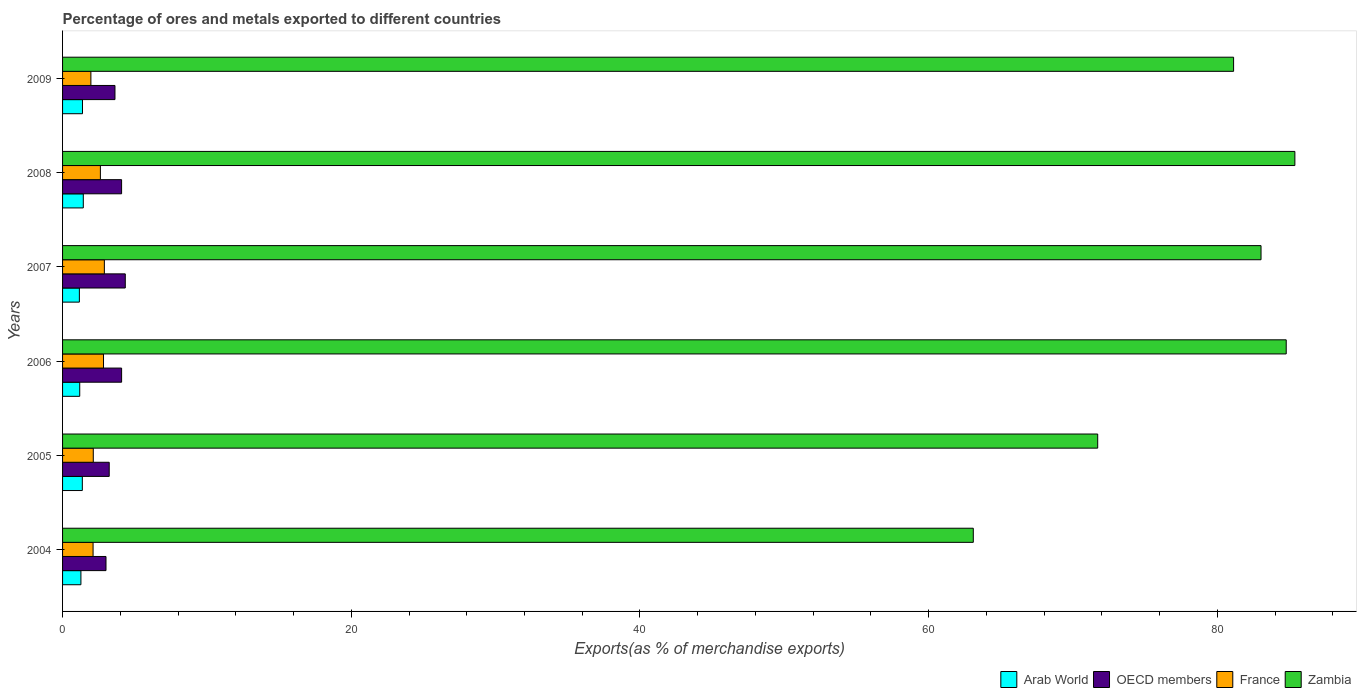How many different coloured bars are there?
Make the answer very short. 4. Are the number of bars per tick equal to the number of legend labels?
Offer a terse response. Yes. How many bars are there on the 3rd tick from the top?
Your answer should be compact. 4. In how many cases, is the number of bars for a given year not equal to the number of legend labels?
Your answer should be very brief. 0. What is the percentage of exports to different countries in Arab World in 2009?
Ensure brevity in your answer.  1.38. Across all years, what is the maximum percentage of exports to different countries in Arab World?
Make the answer very short. 1.44. Across all years, what is the minimum percentage of exports to different countries in France?
Provide a succinct answer. 1.96. In which year was the percentage of exports to different countries in Arab World minimum?
Offer a terse response. 2007. What is the total percentage of exports to different countries in Arab World in the graph?
Provide a short and direct response. 7.81. What is the difference between the percentage of exports to different countries in Arab World in 2007 and that in 2009?
Give a very brief answer. -0.22. What is the difference between the percentage of exports to different countries in OECD members in 2004 and the percentage of exports to different countries in Zambia in 2005?
Give a very brief answer. -68.7. What is the average percentage of exports to different countries in France per year?
Give a very brief answer. 2.43. In the year 2007, what is the difference between the percentage of exports to different countries in Arab World and percentage of exports to different countries in France?
Your answer should be very brief. -1.73. What is the ratio of the percentage of exports to different countries in Arab World in 2007 to that in 2008?
Your answer should be compact. 0.81. Is the difference between the percentage of exports to different countries in Arab World in 2007 and 2009 greater than the difference between the percentage of exports to different countries in France in 2007 and 2009?
Offer a terse response. No. What is the difference between the highest and the second highest percentage of exports to different countries in Arab World?
Give a very brief answer. 0.06. What is the difference between the highest and the lowest percentage of exports to different countries in France?
Offer a terse response. 0.93. Is it the case that in every year, the sum of the percentage of exports to different countries in Arab World and percentage of exports to different countries in OECD members is greater than the sum of percentage of exports to different countries in Zambia and percentage of exports to different countries in France?
Offer a terse response. No. What does the 4th bar from the bottom in 2007 represents?
Your answer should be compact. Zambia. Is it the case that in every year, the sum of the percentage of exports to different countries in Arab World and percentage of exports to different countries in France is greater than the percentage of exports to different countries in Zambia?
Provide a succinct answer. No. Are all the bars in the graph horizontal?
Offer a very short reply. Yes. Are the values on the major ticks of X-axis written in scientific E-notation?
Offer a very short reply. No. Does the graph contain grids?
Your answer should be very brief. No. Where does the legend appear in the graph?
Provide a short and direct response. Bottom right. How many legend labels are there?
Make the answer very short. 4. What is the title of the graph?
Your answer should be compact. Percentage of ores and metals exported to different countries. Does "Micronesia" appear as one of the legend labels in the graph?
Offer a very short reply. No. What is the label or title of the X-axis?
Ensure brevity in your answer.  Exports(as % of merchandise exports). What is the Exports(as % of merchandise exports) in Arab World in 2004?
Provide a succinct answer. 1.27. What is the Exports(as % of merchandise exports) of OECD members in 2004?
Make the answer very short. 3.01. What is the Exports(as % of merchandise exports) of France in 2004?
Provide a short and direct response. 2.11. What is the Exports(as % of merchandise exports) of Zambia in 2004?
Offer a very short reply. 63.09. What is the Exports(as % of merchandise exports) in Arab World in 2005?
Provide a succinct answer. 1.37. What is the Exports(as % of merchandise exports) in OECD members in 2005?
Keep it short and to the point. 3.23. What is the Exports(as % of merchandise exports) in France in 2005?
Keep it short and to the point. 2.13. What is the Exports(as % of merchandise exports) in Zambia in 2005?
Your answer should be compact. 71.71. What is the Exports(as % of merchandise exports) of Arab World in 2006?
Your answer should be very brief. 1.19. What is the Exports(as % of merchandise exports) of OECD members in 2006?
Ensure brevity in your answer.  4.09. What is the Exports(as % of merchandise exports) in France in 2006?
Ensure brevity in your answer.  2.84. What is the Exports(as % of merchandise exports) in Zambia in 2006?
Make the answer very short. 84.77. What is the Exports(as % of merchandise exports) in Arab World in 2007?
Your response must be concise. 1.16. What is the Exports(as % of merchandise exports) in OECD members in 2007?
Keep it short and to the point. 4.35. What is the Exports(as % of merchandise exports) in France in 2007?
Provide a short and direct response. 2.9. What is the Exports(as % of merchandise exports) in Zambia in 2007?
Give a very brief answer. 83.03. What is the Exports(as % of merchandise exports) in Arab World in 2008?
Give a very brief answer. 1.44. What is the Exports(as % of merchandise exports) in OECD members in 2008?
Provide a succinct answer. 4.09. What is the Exports(as % of merchandise exports) of France in 2008?
Ensure brevity in your answer.  2.62. What is the Exports(as % of merchandise exports) of Zambia in 2008?
Offer a terse response. 85.37. What is the Exports(as % of merchandise exports) of Arab World in 2009?
Provide a short and direct response. 1.38. What is the Exports(as % of merchandise exports) of OECD members in 2009?
Your response must be concise. 3.63. What is the Exports(as % of merchandise exports) of France in 2009?
Your answer should be very brief. 1.96. What is the Exports(as % of merchandise exports) in Zambia in 2009?
Your answer should be compact. 81.13. Across all years, what is the maximum Exports(as % of merchandise exports) in Arab World?
Offer a very short reply. 1.44. Across all years, what is the maximum Exports(as % of merchandise exports) of OECD members?
Give a very brief answer. 4.35. Across all years, what is the maximum Exports(as % of merchandise exports) of France?
Ensure brevity in your answer.  2.9. Across all years, what is the maximum Exports(as % of merchandise exports) in Zambia?
Your answer should be compact. 85.37. Across all years, what is the minimum Exports(as % of merchandise exports) in Arab World?
Your answer should be compact. 1.16. Across all years, what is the minimum Exports(as % of merchandise exports) of OECD members?
Keep it short and to the point. 3.01. Across all years, what is the minimum Exports(as % of merchandise exports) in France?
Give a very brief answer. 1.96. Across all years, what is the minimum Exports(as % of merchandise exports) of Zambia?
Provide a short and direct response. 63.09. What is the total Exports(as % of merchandise exports) in Arab World in the graph?
Make the answer very short. 7.81. What is the total Exports(as % of merchandise exports) in OECD members in the graph?
Provide a succinct answer. 22.4. What is the total Exports(as % of merchandise exports) of France in the graph?
Your answer should be very brief. 14.56. What is the total Exports(as % of merchandise exports) of Zambia in the graph?
Give a very brief answer. 469.11. What is the difference between the Exports(as % of merchandise exports) of Arab World in 2004 and that in 2005?
Your answer should be very brief. -0.1. What is the difference between the Exports(as % of merchandise exports) in OECD members in 2004 and that in 2005?
Provide a succinct answer. -0.22. What is the difference between the Exports(as % of merchandise exports) of France in 2004 and that in 2005?
Your response must be concise. -0.01. What is the difference between the Exports(as % of merchandise exports) in Zambia in 2004 and that in 2005?
Give a very brief answer. -8.62. What is the difference between the Exports(as % of merchandise exports) of Arab World in 2004 and that in 2006?
Provide a succinct answer. 0.08. What is the difference between the Exports(as % of merchandise exports) in OECD members in 2004 and that in 2006?
Keep it short and to the point. -1.08. What is the difference between the Exports(as % of merchandise exports) of France in 2004 and that in 2006?
Offer a very short reply. -0.72. What is the difference between the Exports(as % of merchandise exports) in Zambia in 2004 and that in 2006?
Keep it short and to the point. -21.68. What is the difference between the Exports(as % of merchandise exports) of Arab World in 2004 and that in 2007?
Offer a very short reply. 0.11. What is the difference between the Exports(as % of merchandise exports) in OECD members in 2004 and that in 2007?
Keep it short and to the point. -1.34. What is the difference between the Exports(as % of merchandise exports) in France in 2004 and that in 2007?
Offer a terse response. -0.78. What is the difference between the Exports(as % of merchandise exports) in Zambia in 2004 and that in 2007?
Provide a succinct answer. -19.93. What is the difference between the Exports(as % of merchandise exports) in Arab World in 2004 and that in 2008?
Your answer should be compact. -0.17. What is the difference between the Exports(as % of merchandise exports) in OECD members in 2004 and that in 2008?
Provide a short and direct response. -1.08. What is the difference between the Exports(as % of merchandise exports) in France in 2004 and that in 2008?
Your answer should be very brief. -0.51. What is the difference between the Exports(as % of merchandise exports) of Zambia in 2004 and that in 2008?
Provide a succinct answer. -22.28. What is the difference between the Exports(as % of merchandise exports) of Arab World in 2004 and that in 2009?
Keep it short and to the point. -0.11. What is the difference between the Exports(as % of merchandise exports) of OECD members in 2004 and that in 2009?
Provide a short and direct response. -0.62. What is the difference between the Exports(as % of merchandise exports) of France in 2004 and that in 2009?
Give a very brief answer. 0.15. What is the difference between the Exports(as % of merchandise exports) in Zambia in 2004 and that in 2009?
Make the answer very short. -18.03. What is the difference between the Exports(as % of merchandise exports) in Arab World in 2005 and that in 2006?
Keep it short and to the point. 0.18. What is the difference between the Exports(as % of merchandise exports) in OECD members in 2005 and that in 2006?
Your answer should be very brief. -0.86. What is the difference between the Exports(as % of merchandise exports) in France in 2005 and that in 2006?
Keep it short and to the point. -0.71. What is the difference between the Exports(as % of merchandise exports) in Zambia in 2005 and that in 2006?
Offer a terse response. -13.06. What is the difference between the Exports(as % of merchandise exports) of Arab World in 2005 and that in 2007?
Offer a very short reply. 0.2. What is the difference between the Exports(as % of merchandise exports) in OECD members in 2005 and that in 2007?
Give a very brief answer. -1.11. What is the difference between the Exports(as % of merchandise exports) of France in 2005 and that in 2007?
Keep it short and to the point. -0.77. What is the difference between the Exports(as % of merchandise exports) of Zambia in 2005 and that in 2007?
Your answer should be very brief. -11.32. What is the difference between the Exports(as % of merchandise exports) of Arab World in 2005 and that in 2008?
Your answer should be compact. -0.07. What is the difference between the Exports(as % of merchandise exports) in OECD members in 2005 and that in 2008?
Give a very brief answer. -0.86. What is the difference between the Exports(as % of merchandise exports) in France in 2005 and that in 2008?
Offer a terse response. -0.49. What is the difference between the Exports(as % of merchandise exports) in Zambia in 2005 and that in 2008?
Your answer should be compact. -13.66. What is the difference between the Exports(as % of merchandise exports) of Arab World in 2005 and that in 2009?
Give a very brief answer. -0.01. What is the difference between the Exports(as % of merchandise exports) of OECD members in 2005 and that in 2009?
Your answer should be compact. -0.4. What is the difference between the Exports(as % of merchandise exports) of France in 2005 and that in 2009?
Your answer should be very brief. 0.17. What is the difference between the Exports(as % of merchandise exports) of Zambia in 2005 and that in 2009?
Make the answer very short. -9.41. What is the difference between the Exports(as % of merchandise exports) of Arab World in 2006 and that in 2007?
Ensure brevity in your answer.  0.03. What is the difference between the Exports(as % of merchandise exports) in OECD members in 2006 and that in 2007?
Offer a very short reply. -0.25. What is the difference between the Exports(as % of merchandise exports) in France in 2006 and that in 2007?
Offer a terse response. -0.06. What is the difference between the Exports(as % of merchandise exports) in Zambia in 2006 and that in 2007?
Offer a very short reply. 1.74. What is the difference between the Exports(as % of merchandise exports) of Arab World in 2006 and that in 2008?
Keep it short and to the point. -0.25. What is the difference between the Exports(as % of merchandise exports) in OECD members in 2006 and that in 2008?
Your answer should be very brief. 0. What is the difference between the Exports(as % of merchandise exports) in France in 2006 and that in 2008?
Provide a short and direct response. 0.22. What is the difference between the Exports(as % of merchandise exports) of Zambia in 2006 and that in 2008?
Offer a very short reply. -0.6. What is the difference between the Exports(as % of merchandise exports) in Arab World in 2006 and that in 2009?
Your answer should be very brief. -0.19. What is the difference between the Exports(as % of merchandise exports) in OECD members in 2006 and that in 2009?
Provide a short and direct response. 0.46. What is the difference between the Exports(as % of merchandise exports) of France in 2006 and that in 2009?
Keep it short and to the point. 0.87. What is the difference between the Exports(as % of merchandise exports) of Zambia in 2006 and that in 2009?
Keep it short and to the point. 3.65. What is the difference between the Exports(as % of merchandise exports) in Arab World in 2007 and that in 2008?
Your response must be concise. -0.27. What is the difference between the Exports(as % of merchandise exports) in OECD members in 2007 and that in 2008?
Your response must be concise. 0.26. What is the difference between the Exports(as % of merchandise exports) of France in 2007 and that in 2008?
Your response must be concise. 0.28. What is the difference between the Exports(as % of merchandise exports) in Zambia in 2007 and that in 2008?
Ensure brevity in your answer.  -2.34. What is the difference between the Exports(as % of merchandise exports) in Arab World in 2007 and that in 2009?
Give a very brief answer. -0.22. What is the difference between the Exports(as % of merchandise exports) of OECD members in 2007 and that in 2009?
Offer a terse response. 0.71. What is the difference between the Exports(as % of merchandise exports) of France in 2007 and that in 2009?
Make the answer very short. 0.93. What is the difference between the Exports(as % of merchandise exports) in Zambia in 2007 and that in 2009?
Your answer should be very brief. 1.9. What is the difference between the Exports(as % of merchandise exports) of Arab World in 2008 and that in 2009?
Keep it short and to the point. 0.06. What is the difference between the Exports(as % of merchandise exports) in OECD members in 2008 and that in 2009?
Ensure brevity in your answer.  0.46. What is the difference between the Exports(as % of merchandise exports) in France in 2008 and that in 2009?
Your response must be concise. 0.66. What is the difference between the Exports(as % of merchandise exports) of Zambia in 2008 and that in 2009?
Give a very brief answer. 4.25. What is the difference between the Exports(as % of merchandise exports) of Arab World in 2004 and the Exports(as % of merchandise exports) of OECD members in 2005?
Your answer should be very brief. -1.96. What is the difference between the Exports(as % of merchandise exports) of Arab World in 2004 and the Exports(as % of merchandise exports) of France in 2005?
Give a very brief answer. -0.86. What is the difference between the Exports(as % of merchandise exports) of Arab World in 2004 and the Exports(as % of merchandise exports) of Zambia in 2005?
Ensure brevity in your answer.  -70.44. What is the difference between the Exports(as % of merchandise exports) in OECD members in 2004 and the Exports(as % of merchandise exports) in France in 2005?
Your response must be concise. 0.88. What is the difference between the Exports(as % of merchandise exports) in OECD members in 2004 and the Exports(as % of merchandise exports) in Zambia in 2005?
Offer a terse response. -68.7. What is the difference between the Exports(as % of merchandise exports) of France in 2004 and the Exports(as % of merchandise exports) of Zambia in 2005?
Your answer should be compact. -69.6. What is the difference between the Exports(as % of merchandise exports) in Arab World in 2004 and the Exports(as % of merchandise exports) in OECD members in 2006?
Your response must be concise. -2.82. What is the difference between the Exports(as % of merchandise exports) in Arab World in 2004 and the Exports(as % of merchandise exports) in France in 2006?
Provide a succinct answer. -1.57. What is the difference between the Exports(as % of merchandise exports) in Arab World in 2004 and the Exports(as % of merchandise exports) in Zambia in 2006?
Your response must be concise. -83.5. What is the difference between the Exports(as % of merchandise exports) in OECD members in 2004 and the Exports(as % of merchandise exports) in France in 2006?
Keep it short and to the point. 0.17. What is the difference between the Exports(as % of merchandise exports) of OECD members in 2004 and the Exports(as % of merchandise exports) of Zambia in 2006?
Provide a succinct answer. -81.76. What is the difference between the Exports(as % of merchandise exports) in France in 2004 and the Exports(as % of merchandise exports) in Zambia in 2006?
Ensure brevity in your answer.  -82.66. What is the difference between the Exports(as % of merchandise exports) in Arab World in 2004 and the Exports(as % of merchandise exports) in OECD members in 2007?
Make the answer very short. -3.07. What is the difference between the Exports(as % of merchandise exports) of Arab World in 2004 and the Exports(as % of merchandise exports) of France in 2007?
Keep it short and to the point. -1.62. What is the difference between the Exports(as % of merchandise exports) of Arab World in 2004 and the Exports(as % of merchandise exports) of Zambia in 2007?
Your answer should be very brief. -81.76. What is the difference between the Exports(as % of merchandise exports) of OECD members in 2004 and the Exports(as % of merchandise exports) of France in 2007?
Make the answer very short. 0.11. What is the difference between the Exports(as % of merchandise exports) in OECD members in 2004 and the Exports(as % of merchandise exports) in Zambia in 2007?
Your answer should be compact. -80.02. What is the difference between the Exports(as % of merchandise exports) of France in 2004 and the Exports(as % of merchandise exports) of Zambia in 2007?
Ensure brevity in your answer.  -80.91. What is the difference between the Exports(as % of merchandise exports) in Arab World in 2004 and the Exports(as % of merchandise exports) in OECD members in 2008?
Ensure brevity in your answer.  -2.82. What is the difference between the Exports(as % of merchandise exports) of Arab World in 2004 and the Exports(as % of merchandise exports) of France in 2008?
Provide a short and direct response. -1.35. What is the difference between the Exports(as % of merchandise exports) in Arab World in 2004 and the Exports(as % of merchandise exports) in Zambia in 2008?
Your response must be concise. -84.1. What is the difference between the Exports(as % of merchandise exports) of OECD members in 2004 and the Exports(as % of merchandise exports) of France in 2008?
Offer a very short reply. 0.39. What is the difference between the Exports(as % of merchandise exports) of OECD members in 2004 and the Exports(as % of merchandise exports) of Zambia in 2008?
Offer a very short reply. -82.36. What is the difference between the Exports(as % of merchandise exports) in France in 2004 and the Exports(as % of merchandise exports) in Zambia in 2008?
Offer a terse response. -83.26. What is the difference between the Exports(as % of merchandise exports) of Arab World in 2004 and the Exports(as % of merchandise exports) of OECD members in 2009?
Keep it short and to the point. -2.36. What is the difference between the Exports(as % of merchandise exports) of Arab World in 2004 and the Exports(as % of merchandise exports) of France in 2009?
Your response must be concise. -0.69. What is the difference between the Exports(as % of merchandise exports) in Arab World in 2004 and the Exports(as % of merchandise exports) in Zambia in 2009?
Offer a very short reply. -79.85. What is the difference between the Exports(as % of merchandise exports) of OECD members in 2004 and the Exports(as % of merchandise exports) of France in 2009?
Offer a very short reply. 1.05. What is the difference between the Exports(as % of merchandise exports) of OECD members in 2004 and the Exports(as % of merchandise exports) of Zambia in 2009?
Your answer should be compact. -78.12. What is the difference between the Exports(as % of merchandise exports) of France in 2004 and the Exports(as % of merchandise exports) of Zambia in 2009?
Give a very brief answer. -79.01. What is the difference between the Exports(as % of merchandise exports) in Arab World in 2005 and the Exports(as % of merchandise exports) in OECD members in 2006?
Offer a terse response. -2.72. What is the difference between the Exports(as % of merchandise exports) in Arab World in 2005 and the Exports(as % of merchandise exports) in France in 2006?
Provide a succinct answer. -1.47. What is the difference between the Exports(as % of merchandise exports) of Arab World in 2005 and the Exports(as % of merchandise exports) of Zambia in 2006?
Offer a terse response. -83.4. What is the difference between the Exports(as % of merchandise exports) of OECD members in 2005 and the Exports(as % of merchandise exports) of France in 2006?
Your answer should be compact. 0.4. What is the difference between the Exports(as % of merchandise exports) of OECD members in 2005 and the Exports(as % of merchandise exports) of Zambia in 2006?
Offer a terse response. -81.54. What is the difference between the Exports(as % of merchandise exports) in France in 2005 and the Exports(as % of merchandise exports) in Zambia in 2006?
Your answer should be compact. -82.64. What is the difference between the Exports(as % of merchandise exports) of Arab World in 2005 and the Exports(as % of merchandise exports) of OECD members in 2007?
Offer a very short reply. -2.98. What is the difference between the Exports(as % of merchandise exports) in Arab World in 2005 and the Exports(as % of merchandise exports) in France in 2007?
Make the answer very short. -1.53. What is the difference between the Exports(as % of merchandise exports) in Arab World in 2005 and the Exports(as % of merchandise exports) in Zambia in 2007?
Provide a short and direct response. -81.66. What is the difference between the Exports(as % of merchandise exports) in OECD members in 2005 and the Exports(as % of merchandise exports) in France in 2007?
Offer a terse response. 0.34. What is the difference between the Exports(as % of merchandise exports) of OECD members in 2005 and the Exports(as % of merchandise exports) of Zambia in 2007?
Provide a short and direct response. -79.8. What is the difference between the Exports(as % of merchandise exports) of France in 2005 and the Exports(as % of merchandise exports) of Zambia in 2007?
Provide a succinct answer. -80.9. What is the difference between the Exports(as % of merchandise exports) of Arab World in 2005 and the Exports(as % of merchandise exports) of OECD members in 2008?
Ensure brevity in your answer.  -2.72. What is the difference between the Exports(as % of merchandise exports) of Arab World in 2005 and the Exports(as % of merchandise exports) of France in 2008?
Offer a very short reply. -1.25. What is the difference between the Exports(as % of merchandise exports) in Arab World in 2005 and the Exports(as % of merchandise exports) in Zambia in 2008?
Your answer should be very brief. -84. What is the difference between the Exports(as % of merchandise exports) in OECD members in 2005 and the Exports(as % of merchandise exports) in France in 2008?
Ensure brevity in your answer.  0.61. What is the difference between the Exports(as % of merchandise exports) in OECD members in 2005 and the Exports(as % of merchandise exports) in Zambia in 2008?
Make the answer very short. -82.14. What is the difference between the Exports(as % of merchandise exports) in France in 2005 and the Exports(as % of merchandise exports) in Zambia in 2008?
Provide a short and direct response. -83.24. What is the difference between the Exports(as % of merchandise exports) in Arab World in 2005 and the Exports(as % of merchandise exports) in OECD members in 2009?
Keep it short and to the point. -2.26. What is the difference between the Exports(as % of merchandise exports) in Arab World in 2005 and the Exports(as % of merchandise exports) in France in 2009?
Your response must be concise. -0.59. What is the difference between the Exports(as % of merchandise exports) of Arab World in 2005 and the Exports(as % of merchandise exports) of Zambia in 2009?
Provide a short and direct response. -79.76. What is the difference between the Exports(as % of merchandise exports) in OECD members in 2005 and the Exports(as % of merchandise exports) in France in 2009?
Ensure brevity in your answer.  1.27. What is the difference between the Exports(as % of merchandise exports) of OECD members in 2005 and the Exports(as % of merchandise exports) of Zambia in 2009?
Provide a short and direct response. -77.89. What is the difference between the Exports(as % of merchandise exports) in France in 2005 and the Exports(as % of merchandise exports) in Zambia in 2009?
Your answer should be very brief. -79. What is the difference between the Exports(as % of merchandise exports) of Arab World in 2006 and the Exports(as % of merchandise exports) of OECD members in 2007?
Your answer should be very brief. -3.16. What is the difference between the Exports(as % of merchandise exports) in Arab World in 2006 and the Exports(as % of merchandise exports) in France in 2007?
Give a very brief answer. -1.71. What is the difference between the Exports(as % of merchandise exports) of Arab World in 2006 and the Exports(as % of merchandise exports) of Zambia in 2007?
Ensure brevity in your answer.  -81.84. What is the difference between the Exports(as % of merchandise exports) of OECD members in 2006 and the Exports(as % of merchandise exports) of France in 2007?
Your answer should be very brief. 1.2. What is the difference between the Exports(as % of merchandise exports) in OECD members in 2006 and the Exports(as % of merchandise exports) in Zambia in 2007?
Offer a very short reply. -78.94. What is the difference between the Exports(as % of merchandise exports) in France in 2006 and the Exports(as % of merchandise exports) in Zambia in 2007?
Your response must be concise. -80.19. What is the difference between the Exports(as % of merchandise exports) in Arab World in 2006 and the Exports(as % of merchandise exports) in OECD members in 2008?
Give a very brief answer. -2.9. What is the difference between the Exports(as % of merchandise exports) of Arab World in 2006 and the Exports(as % of merchandise exports) of France in 2008?
Your answer should be very brief. -1.43. What is the difference between the Exports(as % of merchandise exports) of Arab World in 2006 and the Exports(as % of merchandise exports) of Zambia in 2008?
Offer a terse response. -84.18. What is the difference between the Exports(as % of merchandise exports) of OECD members in 2006 and the Exports(as % of merchandise exports) of France in 2008?
Ensure brevity in your answer.  1.47. What is the difference between the Exports(as % of merchandise exports) of OECD members in 2006 and the Exports(as % of merchandise exports) of Zambia in 2008?
Keep it short and to the point. -81.28. What is the difference between the Exports(as % of merchandise exports) in France in 2006 and the Exports(as % of merchandise exports) in Zambia in 2008?
Provide a short and direct response. -82.54. What is the difference between the Exports(as % of merchandise exports) of Arab World in 2006 and the Exports(as % of merchandise exports) of OECD members in 2009?
Make the answer very short. -2.44. What is the difference between the Exports(as % of merchandise exports) in Arab World in 2006 and the Exports(as % of merchandise exports) in France in 2009?
Keep it short and to the point. -0.77. What is the difference between the Exports(as % of merchandise exports) of Arab World in 2006 and the Exports(as % of merchandise exports) of Zambia in 2009?
Keep it short and to the point. -79.94. What is the difference between the Exports(as % of merchandise exports) in OECD members in 2006 and the Exports(as % of merchandise exports) in France in 2009?
Your response must be concise. 2.13. What is the difference between the Exports(as % of merchandise exports) of OECD members in 2006 and the Exports(as % of merchandise exports) of Zambia in 2009?
Keep it short and to the point. -77.04. What is the difference between the Exports(as % of merchandise exports) of France in 2006 and the Exports(as % of merchandise exports) of Zambia in 2009?
Offer a terse response. -78.29. What is the difference between the Exports(as % of merchandise exports) in Arab World in 2007 and the Exports(as % of merchandise exports) in OECD members in 2008?
Your answer should be very brief. -2.92. What is the difference between the Exports(as % of merchandise exports) in Arab World in 2007 and the Exports(as % of merchandise exports) in France in 2008?
Your response must be concise. -1.46. What is the difference between the Exports(as % of merchandise exports) of Arab World in 2007 and the Exports(as % of merchandise exports) of Zambia in 2008?
Provide a short and direct response. -84.21. What is the difference between the Exports(as % of merchandise exports) of OECD members in 2007 and the Exports(as % of merchandise exports) of France in 2008?
Make the answer very short. 1.73. What is the difference between the Exports(as % of merchandise exports) in OECD members in 2007 and the Exports(as % of merchandise exports) in Zambia in 2008?
Provide a short and direct response. -81.03. What is the difference between the Exports(as % of merchandise exports) in France in 2007 and the Exports(as % of merchandise exports) in Zambia in 2008?
Your answer should be very brief. -82.48. What is the difference between the Exports(as % of merchandise exports) in Arab World in 2007 and the Exports(as % of merchandise exports) in OECD members in 2009?
Your answer should be very brief. -2.47. What is the difference between the Exports(as % of merchandise exports) of Arab World in 2007 and the Exports(as % of merchandise exports) of France in 2009?
Your answer should be compact. -0.8. What is the difference between the Exports(as % of merchandise exports) of Arab World in 2007 and the Exports(as % of merchandise exports) of Zambia in 2009?
Make the answer very short. -79.96. What is the difference between the Exports(as % of merchandise exports) of OECD members in 2007 and the Exports(as % of merchandise exports) of France in 2009?
Your answer should be very brief. 2.38. What is the difference between the Exports(as % of merchandise exports) of OECD members in 2007 and the Exports(as % of merchandise exports) of Zambia in 2009?
Your answer should be very brief. -76.78. What is the difference between the Exports(as % of merchandise exports) in France in 2007 and the Exports(as % of merchandise exports) in Zambia in 2009?
Ensure brevity in your answer.  -78.23. What is the difference between the Exports(as % of merchandise exports) in Arab World in 2008 and the Exports(as % of merchandise exports) in OECD members in 2009?
Your answer should be very brief. -2.19. What is the difference between the Exports(as % of merchandise exports) of Arab World in 2008 and the Exports(as % of merchandise exports) of France in 2009?
Give a very brief answer. -0.53. What is the difference between the Exports(as % of merchandise exports) of Arab World in 2008 and the Exports(as % of merchandise exports) of Zambia in 2009?
Provide a short and direct response. -79.69. What is the difference between the Exports(as % of merchandise exports) in OECD members in 2008 and the Exports(as % of merchandise exports) in France in 2009?
Provide a short and direct response. 2.13. What is the difference between the Exports(as % of merchandise exports) in OECD members in 2008 and the Exports(as % of merchandise exports) in Zambia in 2009?
Offer a very short reply. -77.04. What is the difference between the Exports(as % of merchandise exports) in France in 2008 and the Exports(as % of merchandise exports) in Zambia in 2009?
Make the answer very short. -78.51. What is the average Exports(as % of merchandise exports) of Arab World per year?
Ensure brevity in your answer.  1.3. What is the average Exports(as % of merchandise exports) in OECD members per year?
Make the answer very short. 3.73. What is the average Exports(as % of merchandise exports) in France per year?
Offer a very short reply. 2.43. What is the average Exports(as % of merchandise exports) in Zambia per year?
Give a very brief answer. 78.18. In the year 2004, what is the difference between the Exports(as % of merchandise exports) of Arab World and Exports(as % of merchandise exports) of OECD members?
Your answer should be compact. -1.74. In the year 2004, what is the difference between the Exports(as % of merchandise exports) of Arab World and Exports(as % of merchandise exports) of France?
Your answer should be compact. -0.84. In the year 2004, what is the difference between the Exports(as % of merchandise exports) of Arab World and Exports(as % of merchandise exports) of Zambia?
Keep it short and to the point. -61.82. In the year 2004, what is the difference between the Exports(as % of merchandise exports) in OECD members and Exports(as % of merchandise exports) in France?
Make the answer very short. 0.89. In the year 2004, what is the difference between the Exports(as % of merchandise exports) of OECD members and Exports(as % of merchandise exports) of Zambia?
Your response must be concise. -60.09. In the year 2004, what is the difference between the Exports(as % of merchandise exports) of France and Exports(as % of merchandise exports) of Zambia?
Your response must be concise. -60.98. In the year 2005, what is the difference between the Exports(as % of merchandise exports) of Arab World and Exports(as % of merchandise exports) of OECD members?
Your answer should be very brief. -1.86. In the year 2005, what is the difference between the Exports(as % of merchandise exports) in Arab World and Exports(as % of merchandise exports) in France?
Your answer should be compact. -0.76. In the year 2005, what is the difference between the Exports(as % of merchandise exports) of Arab World and Exports(as % of merchandise exports) of Zambia?
Offer a terse response. -70.34. In the year 2005, what is the difference between the Exports(as % of merchandise exports) in OECD members and Exports(as % of merchandise exports) in France?
Ensure brevity in your answer.  1.1. In the year 2005, what is the difference between the Exports(as % of merchandise exports) of OECD members and Exports(as % of merchandise exports) of Zambia?
Provide a short and direct response. -68.48. In the year 2005, what is the difference between the Exports(as % of merchandise exports) of France and Exports(as % of merchandise exports) of Zambia?
Your answer should be very brief. -69.58. In the year 2006, what is the difference between the Exports(as % of merchandise exports) of Arab World and Exports(as % of merchandise exports) of OECD members?
Give a very brief answer. -2.9. In the year 2006, what is the difference between the Exports(as % of merchandise exports) of Arab World and Exports(as % of merchandise exports) of France?
Provide a short and direct response. -1.65. In the year 2006, what is the difference between the Exports(as % of merchandise exports) in Arab World and Exports(as % of merchandise exports) in Zambia?
Provide a short and direct response. -83.58. In the year 2006, what is the difference between the Exports(as % of merchandise exports) in OECD members and Exports(as % of merchandise exports) in France?
Your response must be concise. 1.25. In the year 2006, what is the difference between the Exports(as % of merchandise exports) in OECD members and Exports(as % of merchandise exports) in Zambia?
Provide a succinct answer. -80.68. In the year 2006, what is the difference between the Exports(as % of merchandise exports) in France and Exports(as % of merchandise exports) in Zambia?
Your answer should be compact. -81.94. In the year 2007, what is the difference between the Exports(as % of merchandise exports) in Arab World and Exports(as % of merchandise exports) in OECD members?
Your answer should be very brief. -3.18. In the year 2007, what is the difference between the Exports(as % of merchandise exports) in Arab World and Exports(as % of merchandise exports) in France?
Your answer should be very brief. -1.73. In the year 2007, what is the difference between the Exports(as % of merchandise exports) in Arab World and Exports(as % of merchandise exports) in Zambia?
Your response must be concise. -81.86. In the year 2007, what is the difference between the Exports(as % of merchandise exports) of OECD members and Exports(as % of merchandise exports) of France?
Your answer should be compact. 1.45. In the year 2007, what is the difference between the Exports(as % of merchandise exports) of OECD members and Exports(as % of merchandise exports) of Zambia?
Offer a very short reply. -78.68. In the year 2007, what is the difference between the Exports(as % of merchandise exports) in France and Exports(as % of merchandise exports) in Zambia?
Provide a succinct answer. -80.13. In the year 2008, what is the difference between the Exports(as % of merchandise exports) in Arab World and Exports(as % of merchandise exports) in OECD members?
Offer a terse response. -2.65. In the year 2008, what is the difference between the Exports(as % of merchandise exports) in Arab World and Exports(as % of merchandise exports) in France?
Your response must be concise. -1.18. In the year 2008, what is the difference between the Exports(as % of merchandise exports) in Arab World and Exports(as % of merchandise exports) in Zambia?
Ensure brevity in your answer.  -83.94. In the year 2008, what is the difference between the Exports(as % of merchandise exports) of OECD members and Exports(as % of merchandise exports) of France?
Make the answer very short. 1.47. In the year 2008, what is the difference between the Exports(as % of merchandise exports) in OECD members and Exports(as % of merchandise exports) in Zambia?
Your answer should be compact. -81.28. In the year 2008, what is the difference between the Exports(as % of merchandise exports) of France and Exports(as % of merchandise exports) of Zambia?
Provide a short and direct response. -82.75. In the year 2009, what is the difference between the Exports(as % of merchandise exports) of Arab World and Exports(as % of merchandise exports) of OECD members?
Give a very brief answer. -2.25. In the year 2009, what is the difference between the Exports(as % of merchandise exports) in Arab World and Exports(as % of merchandise exports) in France?
Your response must be concise. -0.58. In the year 2009, what is the difference between the Exports(as % of merchandise exports) of Arab World and Exports(as % of merchandise exports) of Zambia?
Your response must be concise. -79.75. In the year 2009, what is the difference between the Exports(as % of merchandise exports) in OECD members and Exports(as % of merchandise exports) in France?
Provide a short and direct response. 1.67. In the year 2009, what is the difference between the Exports(as % of merchandise exports) in OECD members and Exports(as % of merchandise exports) in Zambia?
Your answer should be compact. -77.5. In the year 2009, what is the difference between the Exports(as % of merchandise exports) in France and Exports(as % of merchandise exports) in Zambia?
Offer a terse response. -79.16. What is the ratio of the Exports(as % of merchandise exports) of Arab World in 2004 to that in 2005?
Offer a terse response. 0.93. What is the ratio of the Exports(as % of merchandise exports) in OECD members in 2004 to that in 2005?
Provide a succinct answer. 0.93. What is the ratio of the Exports(as % of merchandise exports) in Zambia in 2004 to that in 2005?
Provide a short and direct response. 0.88. What is the ratio of the Exports(as % of merchandise exports) in Arab World in 2004 to that in 2006?
Provide a succinct answer. 1.07. What is the ratio of the Exports(as % of merchandise exports) in OECD members in 2004 to that in 2006?
Ensure brevity in your answer.  0.74. What is the ratio of the Exports(as % of merchandise exports) in France in 2004 to that in 2006?
Make the answer very short. 0.75. What is the ratio of the Exports(as % of merchandise exports) in Zambia in 2004 to that in 2006?
Your answer should be compact. 0.74. What is the ratio of the Exports(as % of merchandise exports) of Arab World in 2004 to that in 2007?
Offer a very short reply. 1.09. What is the ratio of the Exports(as % of merchandise exports) of OECD members in 2004 to that in 2007?
Make the answer very short. 0.69. What is the ratio of the Exports(as % of merchandise exports) of France in 2004 to that in 2007?
Offer a terse response. 0.73. What is the ratio of the Exports(as % of merchandise exports) of Zambia in 2004 to that in 2007?
Offer a very short reply. 0.76. What is the ratio of the Exports(as % of merchandise exports) of Arab World in 2004 to that in 2008?
Ensure brevity in your answer.  0.89. What is the ratio of the Exports(as % of merchandise exports) in OECD members in 2004 to that in 2008?
Your answer should be very brief. 0.74. What is the ratio of the Exports(as % of merchandise exports) of France in 2004 to that in 2008?
Provide a succinct answer. 0.81. What is the ratio of the Exports(as % of merchandise exports) in Zambia in 2004 to that in 2008?
Give a very brief answer. 0.74. What is the ratio of the Exports(as % of merchandise exports) in Arab World in 2004 to that in 2009?
Ensure brevity in your answer.  0.92. What is the ratio of the Exports(as % of merchandise exports) in OECD members in 2004 to that in 2009?
Make the answer very short. 0.83. What is the ratio of the Exports(as % of merchandise exports) in France in 2004 to that in 2009?
Provide a succinct answer. 1.08. What is the ratio of the Exports(as % of merchandise exports) of Zambia in 2004 to that in 2009?
Your answer should be compact. 0.78. What is the ratio of the Exports(as % of merchandise exports) of Arab World in 2005 to that in 2006?
Your response must be concise. 1.15. What is the ratio of the Exports(as % of merchandise exports) in OECD members in 2005 to that in 2006?
Provide a succinct answer. 0.79. What is the ratio of the Exports(as % of merchandise exports) in France in 2005 to that in 2006?
Provide a succinct answer. 0.75. What is the ratio of the Exports(as % of merchandise exports) in Zambia in 2005 to that in 2006?
Ensure brevity in your answer.  0.85. What is the ratio of the Exports(as % of merchandise exports) in Arab World in 2005 to that in 2007?
Give a very brief answer. 1.18. What is the ratio of the Exports(as % of merchandise exports) of OECD members in 2005 to that in 2007?
Give a very brief answer. 0.74. What is the ratio of the Exports(as % of merchandise exports) in France in 2005 to that in 2007?
Ensure brevity in your answer.  0.73. What is the ratio of the Exports(as % of merchandise exports) of Zambia in 2005 to that in 2007?
Offer a terse response. 0.86. What is the ratio of the Exports(as % of merchandise exports) of Arab World in 2005 to that in 2008?
Provide a short and direct response. 0.95. What is the ratio of the Exports(as % of merchandise exports) of OECD members in 2005 to that in 2008?
Your answer should be compact. 0.79. What is the ratio of the Exports(as % of merchandise exports) of France in 2005 to that in 2008?
Ensure brevity in your answer.  0.81. What is the ratio of the Exports(as % of merchandise exports) in Zambia in 2005 to that in 2008?
Ensure brevity in your answer.  0.84. What is the ratio of the Exports(as % of merchandise exports) in OECD members in 2005 to that in 2009?
Your answer should be very brief. 0.89. What is the ratio of the Exports(as % of merchandise exports) of France in 2005 to that in 2009?
Offer a terse response. 1.08. What is the ratio of the Exports(as % of merchandise exports) in Zambia in 2005 to that in 2009?
Ensure brevity in your answer.  0.88. What is the ratio of the Exports(as % of merchandise exports) in Arab World in 2006 to that in 2007?
Ensure brevity in your answer.  1.02. What is the ratio of the Exports(as % of merchandise exports) of OECD members in 2006 to that in 2007?
Offer a terse response. 0.94. What is the ratio of the Exports(as % of merchandise exports) in France in 2006 to that in 2007?
Offer a very short reply. 0.98. What is the ratio of the Exports(as % of merchandise exports) of Zambia in 2006 to that in 2007?
Provide a succinct answer. 1.02. What is the ratio of the Exports(as % of merchandise exports) in Arab World in 2006 to that in 2008?
Ensure brevity in your answer.  0.83. What is the ratio of the Exports(as % of merchandise exports) in France in 2006 to that in 2008?
Provide a succinct answer. 1.08. What is the ratio of the Exports(as % of merchandise exports) of Arab World in 2006 to that in 2009?
Provide a short and direct response. 0.86. What is the ratio of the Exports(as % of merchandise exports) in OECD members in 2006 to that in 2009?
Provide a succinct answer. 1.13. What is the ratio of the Exports(as % of merchandise exports) of France in 2006 to that in 2009?
Your answer should be compact. 1.45. What is the ratio of the Exports(as % of merchandise exports) in Zambia in 2006 to that in 2009?
Offer a terse response. 1.04. What is the ratio of the Exports(as % of merchandise exports) in Arab World in 2007 to that in 2008?
Your answer should be compact. 0.81. What is the ratio of the Exports(as % of merchandise exports) of OECD members in 2007 to that in 2008?
Your response must be concise. 1.06. What is the ratio of the Exports(as % of merchandise exports) in France in 2007 to that in 2008?
Your answer should be very brief. 1.11. What is the ratio of the Exports(as % of merchandise exports) of Zambia in 2007 to that in 2008?
Make the answer very short. 0.97. What is the ratio of the Exports(as % of merchandise exports) of Arab World in 2007 to that in 2009?
Make the answer very short. 0.84. What is the ratio of the Exports(as % of merchandise exports) of OECD members in 2007 to that in 2009?
Provide a short and direct response. 1.2. What is the ratio of the Exports(as % of merchandise exports) of France in 2007 to that in 2009?
Your answer should be compact. 1.48. What is the ratio of the Exports(as % of merchandise exports) of Zambia in 2007 to that in 2009?
Your response must be concise. 1.02. What is the ratio of the Exports(as % of merchandise exports) in Arab World in 2008 to that in 2009?
Ensure brevity in your answer.  1.04. What is the ratio of the Exports(as % of merchandise exports) of OECD members in 2008 to that in 2009?
Give a very brief answer. 1.13. What is the ratio of the Exports(as % of merchandise exports) of France in 2008 to that in 2009?
Provide a succinct answer. 1.34. What is the ratio of the Exports(as % of merchandise exports) in Zambia in 2008 to that in 2009?
Provide a short and direct response. 1.05. What is the difference between the highest and the second highest Exports(as % of merchandise exports) in Arab World?
Offer a terse response. 0.06. What is the difference between the highest and the second highest Exports(as % of merchandise exports) in OECD members?
Offer a very short reply. 0.25. What is the difference between the highest and the second highest Exports(as % of merchandise exports) of France?
Your answer should be very brief. 0.06. What is the difference between the highest and the second highest Exports(as % of merchandise exports) in Zambia?
Your answer should be very brief. 0.6. What is the difference between the highest and the lowest Exports(as % of merchandise exports) in Arab World?
Your answer should be very brief. 0.27. What is the difference between the highest and the lowest Exports(as % of merchandise exports) in OECD members?
Your response must be concise. 1.34. What is the difference between the highest and the lowest Exports(as % of merchandise exports) in France?
Make the answer very short. 0.93. What is the difference between the highest and the lowest Exports(as % of merchandise exports) in Zambia?
Keep it short and to the point. 22.28. 